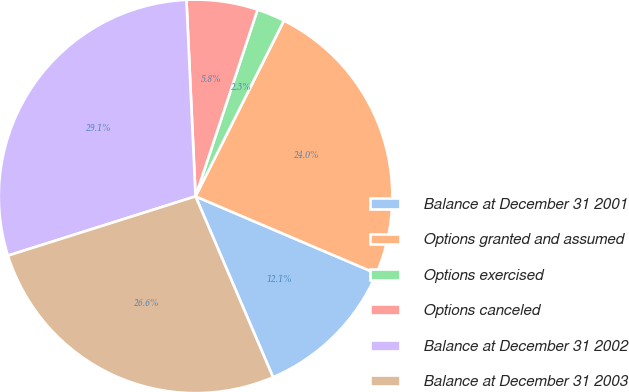Convert chart. <chart><loc_0><loc_0><loc_500><loc_500><pie_chart><fcel>Balance at December 31 2001<fcel>Options granted and assumed<fcel>Options exercised<fcel>Options canceled<fcel>Balance at December 31 2002<fcel>Balance at December 31 2003<nl><fcel>12.14%<fcel>24.0%<fcel>2.31%<fcel>5.84%<fcel>29.13%<fcel>26.57%<nl></chart> 